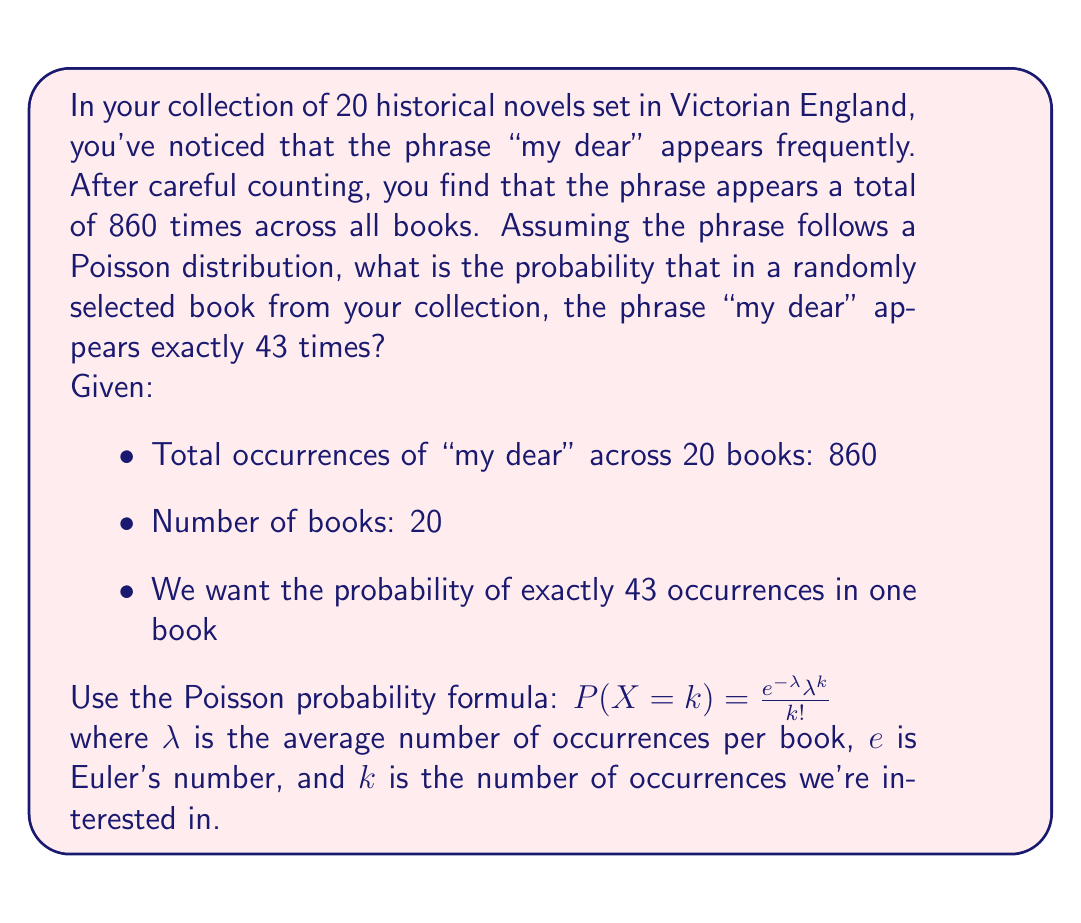Could you help me with this problem? Let's approach this step-by-step:

1) First, we need to calculate $\lambda$, the average number of occurrences per book:
   $\lambda = \frac{\text{Total occurrences}}{\text{Number of books}} = \frac{860}{20} = 43$

2) Now we have all the components for the Poisson formula:
   $\lambda = 43$
   $k = 43$ (we want exactly 43 occurrences)
   $e \approx 2.71828$ (Euler's number)

3) Let's substitute these into the Poisson probability formula:

   $P(X = 43) = \frac{e^{-43} 43^{43}}{43!}$

4) This is a complex calculation, so we'll use a calculator or computer for the actual computation:

   $P(X = 43) \approx 0.0608$

5) To interpret this result: there is approximately a 6.08% chance that a randomly selected book from your collection will contain exactly 43 occurrences of the phrase "my dear".

Note: This model assumes that the occurrences of "my dear" are independent and occur at a constant average rate, which may not perfectly reflect reality in literature. However, it provides a reasonable approximation for this analysis.
Answer: The probability is approximately 0.0608 or 6.08%. 